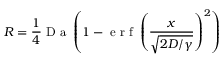Convert formula to latex. <formula><loc_0><loc_0><loc_500><loc_500>R = \frac { 1 } { 4 } D a \left ( 1 - e r f \left ( \frac { x } { \sqrt { 2 D / \gamma } } \right ) ^ { 2 } \right )</formula> 